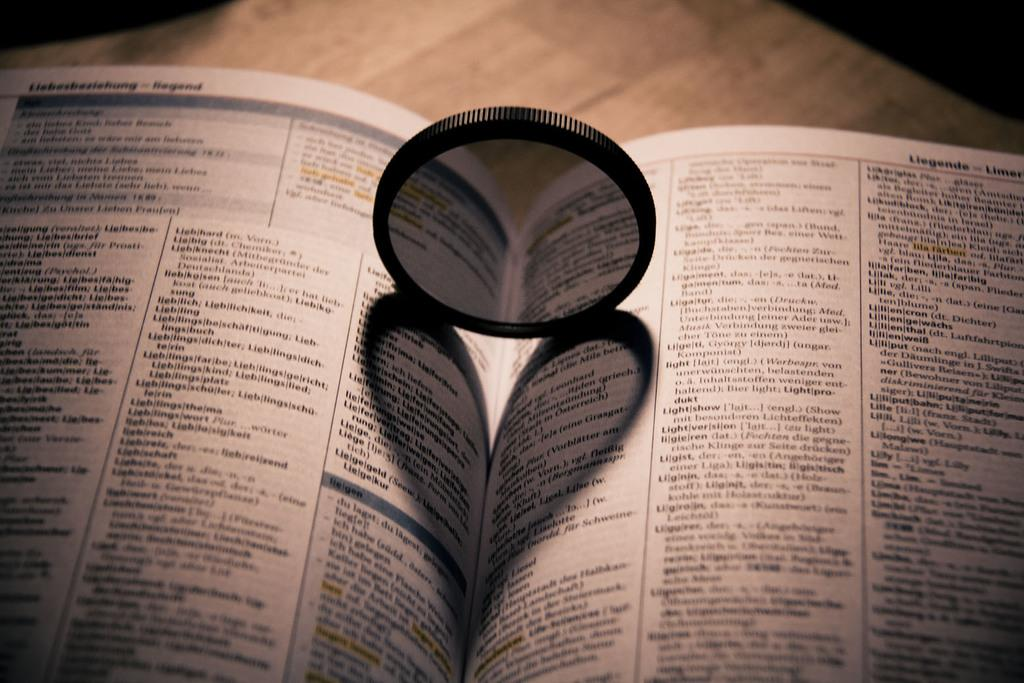<image>
Relay a brief, clear account of the picture shown. A phone book sits open on a table and lists many last names, including Liegende. 